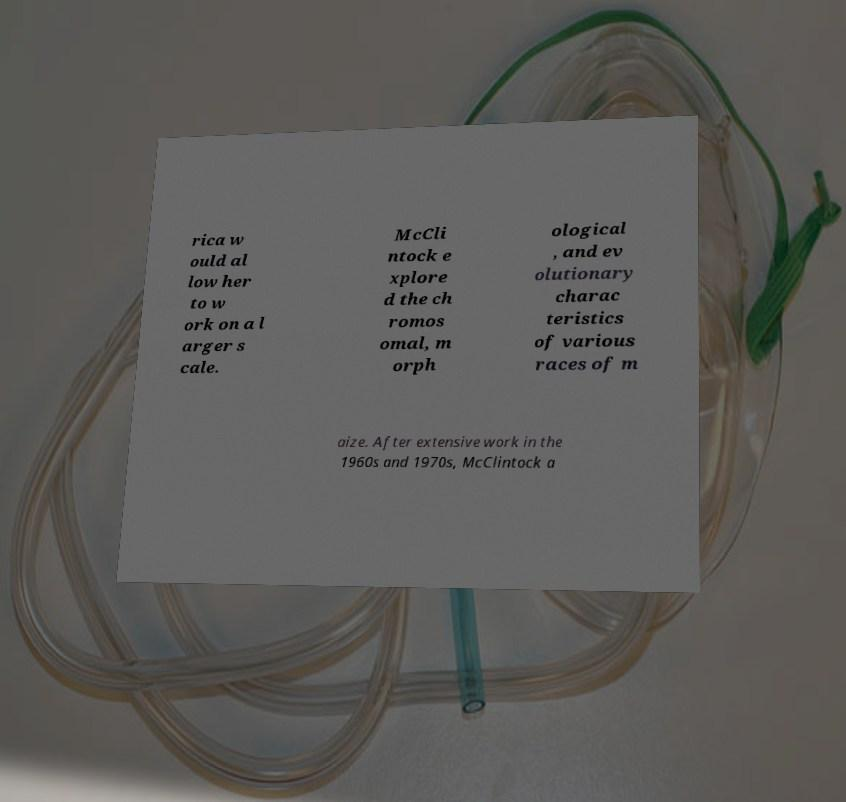Can you read and provide the text displayed in the image?This photo seems to have some interesting text. Can you extract and type it out for me? rica w ould al low her to w ork on a l arger s cale. McCli ntock e xplore d the ch romos omal, m orph ological , and ev olutionary charac teristics of various races of m aize. After extensive work in the 1960s and 1970s, McClintock a 